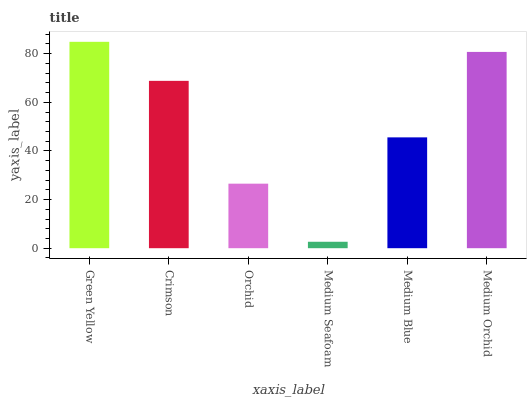Is Medium Seafoam the minimum?
Answer yes or no. Yes. Is Green Yellow the maximum?
Answer yes or no. Yes. Is Crimson the minimum?
Answer yes or no. No. Is Crimson the maximum?
Answer yes or no. No. Is Green Yellow greater than Crimson?
Answer yes or no. Yes. Is Crimson less than Green Yellow?
Answer yes or no. Yes. Is Crimson greater than Green Yellow?
Answer yes or no. No. Is Green Yellow less than Crimson?
Answer yes or no. No. Is Crimson the high median?
Answer yes or no. Yes. Is Medium Blue the low median?
Answer yes or no. Yes. Is Medium Blue the high median?
Answer yes or no. No. Is Medium Orchid the low median?
Answer yes or no. No. 